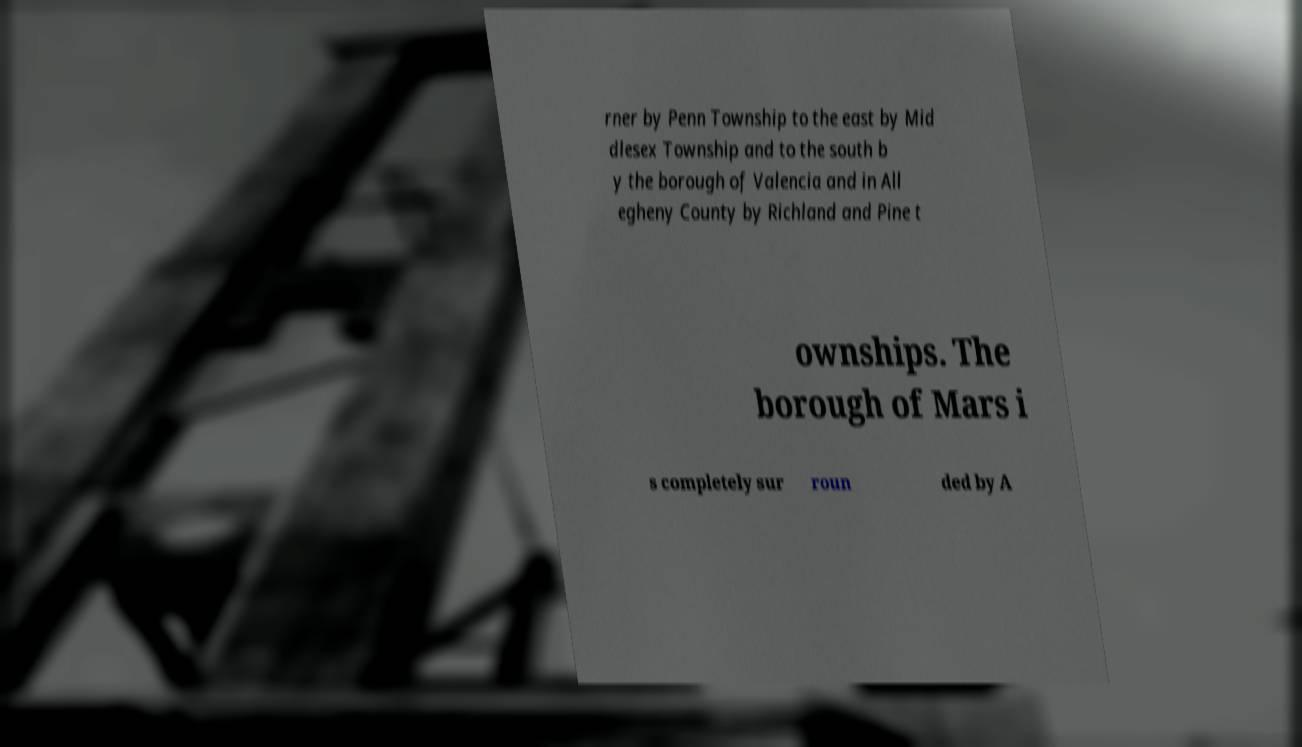There's text embedded in this image that I need extracted. Can you transcribe it verbatim? rner by Penn Township to the east by Mid dlesex Township and to the south b y the borough of Valencia and in All egheny County by Richland and Pine t ownships. The borough of Mars i s completely sur roun ded by A 